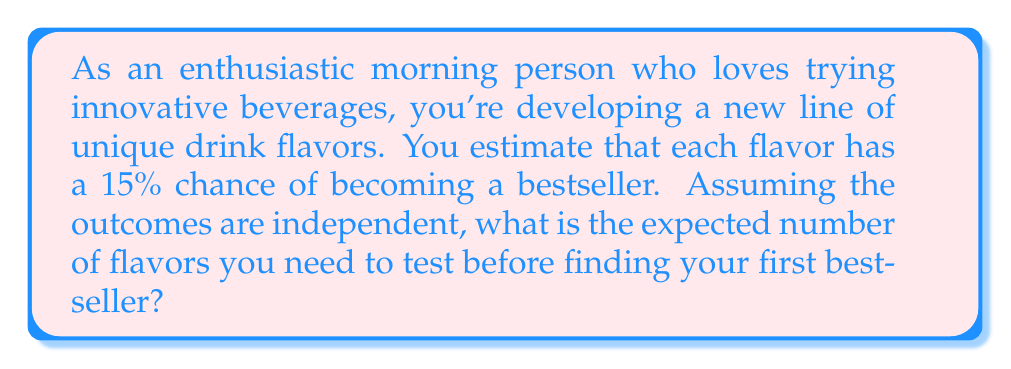What is the answer to this math problem? Let's approach this step-by-step using the concept of geometric distribution:

1) This scenario follows a geometric distribution, where we're looking for the expected number of trials until the first success.

2) The probability of success (finding a bestseller) for each trial is $p = 0.15$ or 15%.

3) For a geometric distribution, the expected value is given by the formula:

   $$E(X) = \frac{1}{p}$$

   Where $X$ is the random variable representing the number of trials until success, and $p$ is the probability of success on each trial.

4) Substituting our value:

   $$E(X) = \frac{1}{0.15}$$

5) Calculating:

   $$E(X) = 6.67$$

6) Since we can only test a whole number of flavors, we round up to the nearest integer.

Therefore, you can expect to test 7 flavors before finding a bestseller.
Answer: 7 flavors 